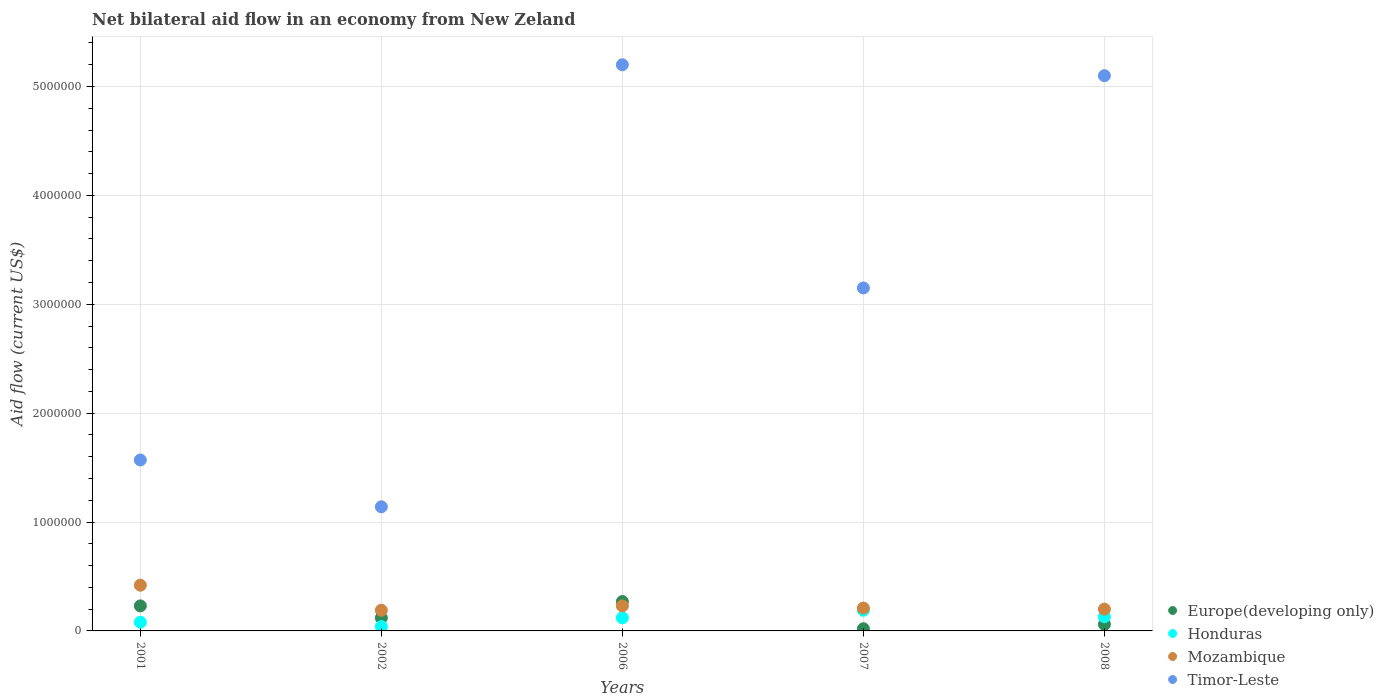How many different coloured dotlines are there?
Provide a succinct answer. 4. What is the net bilateral aid flow in Timor-Leste in 2007?
Your response must be concise. 3.15e+06. Across all years, what is the minimum net bilateral aid flow in Timor-Leste?
Give a very brief answer. 1.14e+06. In which year was the net bilateral aid flow in Timor-Leste minimum?
Provide a succinct answer. 2002. What is the total net bilateral aid flow in Timor-Leste in the graph?
Offer a very short reply. 1.62e+07. What is the difference between the net bilateral aid flow in Mozambique in 2001 and that in 2007?
Provide a short and direct response. 2.10e+05. What is the difference between the net bilateral aid flow in Europe(developing only) in 2002 and the net bilateral aid flow in Timor-Leste in 2007?
Your response must be concise. -3.03e+06. In the year 2008, what is the difference between the net bilateral aid flow in Honduras and net bilateral aid flow in Mozambique?
Your answer should be compact. -7.00e+04. In how many years, is the net bilateral aid flow in Timor-Leste greater than 3200000 US$?
Make the answer very short. 2. What is the ratio of the net bilateral aid flow in Mozambique in 2007 to that in 2008?
Your answer should be compact. 1.05. Is the sum of the net bilateral aid flow in Timor-Leste in 2001 and 2007 greater than the maximum net bilateral aid flow in Europe(developing only) across all years?
Your answer should be compact. Yes. Does the net bilateral aid flow in Mozambique monotonically increase over the years?
Provide a succinct answer. No. How many years are there in the graph?
Give a very brief answer. 5. What is the difference between two consecutive major ticks on the Y-axis?
Provide a short and direct response. 1.00e+06. Are the values on the major ticks of Y-axis written in scientific E-notation?
Provide a succinct answer. No. Where does the legend appear in the graph?
Ensure brevity in your answer.  Bottom right. How are the legend labels stacked?
Offer a terse response. Vertical. What is the title of the graph?
Your answer should be very brief. Net bilateral aid flow in an economy from New Zeland. Does "Turkmenistan" appear as one of the legend labels in the graph?
Provide a short and direct response. No. What is the label or title of the Y-axis?
Give a very brief answer. Aid flow (current US$). What is the Aid flow (current US$) in Honduras in 2001?
Ensure brevity in your answer.  8.00e+04. What is the Aid flow (current US$) in Timor-Leste in 2001?
Make the answer very short. 1.57e+06. What is the Aid flow (current US$) in Europe(developing only) in 2002?
Keep it short and to the point. 1.20e+05. What is the Aid flow (current US$) of Honduras in 2002?
Make the answer very short. 4.00e+04. What is the Aid flow (current US$) of Mozambique in 2002?
Keep it short and to the point. 1.90e+05. What is the Aid flow (current US$) of Timor-Leste in 2002?
Offer a terse response. 1.14e+06. What is the Aid flow (current US$) in Honduras in 2006?
Provide a succinct answer. 1.20e+05. What is the Aid flow (current US$) of Timor-Leste in 2006?
Provide a succinct answer. 5.20e+06. What is the Aid flow (current US$) of Timor-Leste in 2007?
Offer a terse response. 3.15e+06. What is the Aid flow (current US$) of Honduras in 2008?
Your answer should be compact. 1.30e+05. What is the Aid flow (current US$) of Timor-Leste in 2008?
Ensure brevity in your answer.  5.10e+06. Across all years, what is the maximum Aid flow (current US$) in Timor-Leste?
Give a very brief answer. 5.20e+06. Across all years, what is the minimum Aid flow (current US$) in Europe(developing only)?
Provide a succinct answer. 2.00e+04. Across all years, what is the minimum Aid flow (current US$) in Honduras?
Give a very brief answer. 4.00e+04. Across all years, what is the minimum Aid flow (current US$) in Mozambique?
Provide a succinct answer. 1.90e+05. Across all years, what is the minimum Aid flow (current US$) in Timor-Leste?
Ensure brevity in your answer.  1.14e+06. What is the total Aid flow (current US$) of Europe(developing only) in the graph?
Offer a terse response. 7.00e+05. What is the total Aid flow (current US$) of Honduras in the graph?
Offer a very short reply. 5.60e+05. What is the total Aid flow (current US$) of Mozambique in the graph?
Give a very brief answer. 1.25e+06. What is the total Aid flow (current US$) of Timor-Leste in the graph?
Give a very brief answer. 1.62e+07. What is the difference between the Aid flow (current US$) in Honduras in 2001 and that in 2002?
Make the answer very short. 4.00e+04. What is the difference between the Aid flow (current US$) in Mozambique in 2001 and that in 2002?
Ensure brevity in your answer.  2.30e+05. What is the difference between the Aid flow (current US$) in Mozambique in 2001 and that in 2006?
Give a very brief answer. 1.90e+05. What is the difference between the Aid flow (current US$) of Timor-Leste in 2001 and that in 2006?
Provide a succinct answer. -3.63e+06. What is the difference between the Aid flow (current US$) in Honduras in 2001 and that in 2007?
Provide a short and direct response. -1.10e+05. What is the difference between the Aid flow (current US$) of Timor-Leste in 2001 and that in 2007?
Offer a terse response. -1.58e+06. What is the difference between the Aid flow (current US$) of Europe(developing only) in 2001 and that in 2008?
Your answer should be compact. 1.70e+05. What is the difference between the Aid flow (current US$) of Timor-Leste in 2001 and that in 2008?
Offer a very short reply. -3.53e+06. What is the difference between the Aid flow (current US$) of Europe(developing only) in 2002 and that in 2006?
Keep it short and to the point. -1.50e+05. What is the difference between the Aid flow (current US$) of Mozambique in 2002 and that in 2006?
Your response must be concise. -4.00e+04. What is the difference between the Aid flow (current US$) of Timor-Leste in 2002 and that in 2006?
Keep it short and to the point. -4.06e+06. What is the difference between the Aid flow (current US$) of Europe(developing only) in 2002 and that in 2007?
Ensure brevity in your answer.  1.00e+05. What is the difference between the Aid flow (current US$) of Honduras in 2002 and that in 2007?
Offer a terse response. -1.50e+05. What is the difference between the Aid flow (current US$) in Mozambique in 2002 and that in 2007?
Provide a succinct answer. -2.00e+04. What is the difference between the Aid flow (current US$) of Timor-Leste in 2002 and that in 2007?
Give a very brief answer. -2.01e+06. What is the difference between the Aid flow (current US$) in Timor-Leste in 2002 and that in 2008?
Ensure brevity in your answer.  -3.96e+06. What is the difference between the Aid flow (current US$) of Europe(developing only) in 2006 and that in 2007?
Your answer should be very brief. 2.50e+05. What is the difference between the Aid flow (current US$) in Honduras in 2006 and that in 2007?
Your answer should be compact. -7.00e+04. What is the difference between the Aid flow (current US$) of Timor-Leste in 2006 and that in 2007?
Give a very brief answer. 2.05e+06. What is the difference between the Aid flow (current US$) in Europe(developing only) in 2006 and that in 2008?
Your answer should be very brief. 2.10e+05. What is the difference between the Aid flow (current US$) of Honduras in 2006 and that in 2008?
Your answer should be compact. -10000. What is the difference between the Aid flow (current US$) in Mozambique in 2006 and that in 2008?
Your answer should be compact. 3.00e+04. What is the difference between the Aid flow (current US$) of Timor-Leste in 2006 and that in 2008?
Provide a short and direct response. 1.00e+05. What is the difference between the Aid flow (current US$) of Honduras in 2007 and that in 2008?
Provide a short and direct response. 6.00e+04. What is the difference between the Aid flow (current US$) in Mozambique in 2007 and that in 2008?
Make the answer very short. 10000. What is the difference between the Aid flow (current US$) of Timor-Leste in 2007 and that in 2008?
Your answer should be compact. -1.95e+06. What is the difference between the Aid flow (current US$) of Europe(developing only) in 2001 and the Aid flow (current US$) of Honduras in 2002?
Ensure brevity in your answer.  1.90e+05. What is the difference between the Aid flow (current US$) of Europe(developing only) in 2001 and the Aid flow (current US$) of Timor-Leste in 2002?
Offer a terse response. -9.10e+05. What is the difference between the Aid flow (current US$) of Honduras in 2001 and the Aid flow (current US$) of Timor-Leste in 2002?
Provide a short and direct response. -1.06e+06. What is the difference between the Aid flow (current US$) in Mozambique in 2001 and the Aid flow (current US$) in Timor-Leste in 2002?
Give a very brief answer. -7.20e+05. What is the difference between the Aid flow (current US$) in Europe(developing only) in 2001 and the Aid flow (current US$) in Honduras in 2006?
Provide a succinct answer. 1.10e+05. What is the difference between the Aid flow (current US$) in Europe(developing only) in 2001 and the Aid flow (current US$) in Mozambique in 2006?
Your answer should be very brief. 0. What is the difference between the Aid flow (current US$) of Europe(developing only) in 2001 and the Aid flow (current US$) of Timor-Leste in 2006?
Ensure brevity in your answer.  -4.97e+06. What is the difference between the Aid flow (current US$) in Honduras in 2001 and the Aid flow (current US$) in Mozambique in 2006?
Make the answer very short. -1.50e+05. What is the difference between the Aid flow (current US$) of Honduras in 2001 and the Aid flow (current US$) of Timor-Leste in 2006?
Give a very brief answer. -5.12e+06. What is the difference between the Aid flow (current US$) of Mozambique in 2001 and the Aid flow (current US$) of Timor-Leste in 2006?
Offer a very short reply. -4.78e+06. What is the difference between the Aid flow (current US$) in Europe(developing only) in 2001 and the Aid flow (current US$) in Honduras in 2007?
Offer a terse response. 4.00e+04. What is the difference between the Aid flow (current US$) in Europe(developing only) in 2001 and the Aid flow (current US$) in Timor-Leste in 2007?
Your answer should be compact. -2.92e+06. What is the difference between the Aid flow (current US$) of Honduras in 2001 and the Aid flow (current US$) of Timor-Leste in 2007?
Provide a succinct answer. -3.07e+06. What is the difference between the Aid flow (current US$) of Mozambique in 2001 and the Aid flow (current US$) of Timor-Leste in 2007?
Keep it short and to the point. -2.73e+06. What is the difference between the Aid flow (current US$) of Europe(developing only) in 2001 and the Aid flow (current US$) of Honduras in 2008?
Offer a very short reply. 1.00e+05. What is the difference between the Aid flow (current US$) of Europe(developing only) in 2001 and the Aid flow (current US$) of Mozambique in 2008?
Make the answer very short. 3.00e+04. What is the difference between the Aid flow (current US$) in Europe(developing only) in 2001 and the Aid flow (current US$) in Timor-Leste in 2008?
Your answer should be very brief. -4.87e+06. What is the difference between the Aid flow (current US$) of Honduras in 2001 and the Aid flow (current US$) of Mozambique in 2008?
Keep it short and to the point. -1.20e+05. What is the difference between the Aid flow (current US$) of Honduras in 2001 and the Aid flow (current US$) of Timor-Leste in 2008?
Offer a very short reply. -5.02e+06. What is the difference between the Aid flow (current US$) of Mozambique in 2001 and the Aid flow (current US$) of Timor-Leste in 2008?
Offer a very short reply. -4.68e+06. What is the difference between the Aid flow (current US$) in Europe(developing only) in 2002 and the Aid flow (current US$) in Mozambique in 2006?
Make the answer very short. -1.10e+05. What is the difference between the Aid flow (current US$) of Europe(developing only) in 2002 and the Aid flow (current US$) of Timor-Leste in 2006?
Provide a short and direct response. -5.08e+06. What is the difference between the Aid flow (current US$) in Honduras in 2002 and the Aid flow (current US$) in Mozambique in 2006?
Ensure brevity in your answer.  -1.90e+05. What is the difference between the Aid flow (current US$) of Honduras in 2002 and the Aid flow (current US$) of Timor-Leste in 2006?
Offer a very short reply. -5.16e+06. What is the difference between the Aid flow (current US$) in Mozambique in 2002 and the Aid flow (current US$) in Timor-Leste in 2006?
Give a very brief answer. -5.01e+06. What is the difference between the Aid flow (current US$) of Europe(developing only) in 2002 and the Aid flow (current US$) of Honduras in 2007?
Offer a very short reply. -7.00e+04. What is the difference between the Aid flow (current US$) of Europe(developing only) in 2002 and the Aid flow (current US$) of Timor-Leste in 2007?
Provide a succinct answer. -3.03e+06. What is the difference between the Aid flow (current US$) in Honduras in 2002 and the Aid flow (current US$) in Mozambique in 2007?
Give a very brief answer. -1.70e+05. What is the difference between the Aid flow (current US$) of Honduras in 2002 and the Aid flow (current US$) of Timor-Leste in 2007?
Provide a succinct answer. -3.11e+06. What is the difference between the Aid flow (current US$) in Mozambique in 2002 and the Aid flow (current US$) in Timor-Leste in 2007?
Ensure brevity in your answer.  -2.96e+06. What is the difference between the Aid flow (current US$) in Europe(developing only) in 2002 and the Aid flow (current US$) in Timor-Leste in 2008?
Your response must be concise. -4.98e+06. What is the difference between the Aid flow (current US$) of Honduras in 2002 and the Aid flow (current US$) of Mozambique in 2008?
Your answer should be compact. -1.60e+05. What is the difference between the Aid flow (current US$) of Honduras in 2002 and the Aid flow (current US$) of Timor-Leste in 2008?
Offer a terse response. -5.06e+06. What is the difference between the Aid flow (current US$) in Mozambique in 2002 and the Aid flow (current US$) in Timor-Leste in 2008?
Your response must be concise. -4.91e+06. What is the difference between the Aid flow (current US$) of Europe(developing only) in 2006 and the Aid flow (current US$) of Honduras in 2007?
Your response must be concise. 8.00e+04. What is the difference between the Aid flow (current US$) of Europe(developing only) in 2006 and the Aid flow (current US$) of Mozambique in 2007?
Provide a succinct answer. 6.00e+04. What is the difference between the Aid flow (current US$) of Europe(developing only) in 2006 and the Aid flow (current US$) of Timor-Leste in 2007?
Your answer should be compact. -2.88e+06. What is the difference between the Aid flow (current US$) in Honduras in 2006 and the Aid flow (current US$) in Mozambique in 2007?
Ensure brevity in your answer.  -9.00e+04. What is the difference between the Aid flow (current US$) in Honduras in 2006 and the Aid flow (current US$) in Timor-Leste in 2007?
Provide a short and direct response. -3.03e+06. What is the difference between the Aid flow (current US$) of Mozambique in 2006 and the Aid flow (current US$) of Timor-Leste in 2007?
Keep it short and to the point. -2.92e+06. What is the difference between the Aid flow (current US$) in Europe(developing only) in 2006 and the Aid flow (current US$) in Mozambique in 2008?
Make the answer very short. 7.00e+04. What is the difference between the Aid flow (current US$) of Europe(developing only) in 2006 and the Aid flow (current US$) of Timor-Leste in 2008?
Your response must be concise. -4.83e+06. What is the difference between the Aid flow (current US$) in Honduras in 2006 and the Aid flow (current US$) in Mozambique in 2008?
Offer a terse response. -8.00e+04. What is the difference between the Aid flow (current US$) of Honduras in 2006 and the Aid flow (current US$) of Timor-Leste in 2008?
Your response must be concise. -4.98e+06. What is the difference between the Aid flow (current US$) in Mozambique in 2006 and the Aid flow (current US$) in Timor-Leste in 2008?
Your response must be concise. -4.87e+06. What is the difference between the Aid flow (current US$) of Europe(developing only) in 2007 and the Aid flow (current US$) of Timor-Leste in 2008?
Offer a terse response. -5.08e+06. What is the difference between the Aid flow (current US$) of Honduras in 2007 and the Aid flow (current US$) of Mozambique in 2008?
Ensure brevity in your answer.  -10000. What is the difference between the Aid flow (current US$) of Honduras in 2007 and the Aid flow (current US$) of Timor-Leste in 2008?
Keep it short and to the point. -4.91e+06. What is the difference between the Aid flow (current US$) in Mozambique in 2007 and the Aid flow (current US$) in Timor-Leste in 2008?
Ensure brevity in your answer.  -4.89e+06. What is the average Aid flow (current US$) in Europe(developing only) per year?
Your answer should be very brief. 1.40e+05. What is the average Aid flow (current US$) in Honduras per year?
Your answer should be compact. 1.12e+05. What is the average Aid flow (current US$) in Mozambique per year?
Ensure brevity in your answer.  2.50e+05. What is the average Aid flow (current US$) of Timor-Leste per year?
Ensure brevity in your answer.  3.23e+06. In the year 2001, what is the difference between the Aid flow (current US$) of Europe(developing only) and Aid flow (current US$) of Timor-Leste?
Ensure brevity in your answer.  -1.34e+06. In the year 2001, what is the difference between the Aid flow (current US$) in Honduras and Aid flow (current US$) in Mozambique?
Your response must be concise. -3.40e+05. In the year 2001, what is the difference between the Aid flow (current US$) of Honduras and Aid flow (current US$) of Timor-Leste?
Make the answer very short. -1.49e+06. In the year 2001, what is the difference between the Aid flow (current US$) in Mozambique and Aid flow (current US$) in Timor-Leste?
Offer a very short reply. -1.15e+06. In the year 2002, what is the difference between the Aid flow (current US$) of Europe(developing only) and Aid flow (current US$) of Honduras?
Provide a short and direct response. 8.00e+04. In the year 2002, what is the difference between the Aid flow (current US$) of Europe(developing only) and Aid flow (current US$) of Mozambique?
Your answer should be very brief. -7.00e+04. In the year 2002, what is the difference between the Aid flow (current US$) of Europe(developing only) and Aid flow (current US$) of Timor-Leste?
Offer a very short reply. -1.02e+06. In the year 2002, what is the difference between the Aid flow (current US$) in Honduras and Aid flow (current US$) in Timor-Leste?
Your answer should be very brief. -1.10e+06. In the year 2002, what is the difference between the Aid flow (current US$) of Mozambique and Aid flow (current US$) of Timor-Leste?
Your response must be concise. -9.50e+05. In the year 2006, what is the difference between the Aid flow (current US$) in Europe(developing only) and Aid flow (current US$) in Honduras?
Your answer should be compact. 1.50e+05. In the year 2006, what is the difference between the Aid flow (current US$) in Europe(developing only) and Aid flow (current US$) in Timor-Leste?
Make the answer very short. -4.93e+06. In the year 2006, what is the difference between the Aid flow (current US$) in Honduras and Aid flow (current US$) in Mozambique?
Your answer should be very brief. -1.10e+05. In the year 2006, what is the difference between the Aid flow (current US$) of Honduras and Aid flow (current US$) of Timor-Leste?
Ensure brevity in your answer.  -5.08e+06. In the year 2006, what is the difference between the Aid flow (current US$) in Mozambique and Aid flow (current US$) in Timor-Leste?
Provide a succinct answer. -4.97e+06. In the year 2007, what is the difference between the Aid flow (current US$) in Europe(developing only) and Aid flow (current US$) in Timor-Leste?
Provide a succinct answer. -3.13e+06. In the year 2007, what is the difference between the Aid flow (current US$) in Honduras and Aid flow (current US$) in Mozambique?
Offer a very short reply. -2.00e+04. In the year 2007, what is the difference between the Aid flow (current US$) of Honduras and Aid flow (current US$) of Timor-Leste?
Your answer should be very brief. -2.96e+06. In the year 2007, what is the difference between the Aid flow (current US$) in Mozambique and Aid flow (current US$) in Timor-Leste?
Keep it short and to the point. -2.94e+06. In the year 2008, what is the difference between the Aid flow (current US$) in Europe(developing only) and Aid flow (current US$) in Honduras?
Provide a short and direct response. -7.00e+04. In the year 2008, what is the difference between the Aid flow (current US$) of Europe(developing only) and Aid flow (current US$) of Mozambique?
Offer a very short reply. -1.40e+05. In the year 2008, what is the difference between the Aid flow (current US$) of Europe(developing only) and Aid flow (current US$) of Timor-Leste?
Ensure brevity in your answer.  -5.04e+06. In the year 2008, what is the difference between the Aid flow (current US$) of Honduras and Aid flow (current US$) of Timor-Leste?
Provide a short and direct response. -4.97e+06. In the year 2008, what is the difference between the Aid flow (current US$) in Mozambique and Aid flow (current US$) in Timor-Leste?
Offer a very short reply. -4.90e+06. What is the ratio of the Aid flow (current US$) in Europe(developing only) in 2001 to that in 2002?
Offer a terse response. 1.92. What is the ratio of the Aid flow (current US$) of Honduras in 2001 to that in 2002?
Provide a short and direct response. 2. What is the ratio of the Aid flow (current US$) of Mozambique in 2001 to that in 2002?
Your answer should be compact. 2.21. What is the ratio of the Aid flow (current US$) of Timor-Leste in 2001 to that in 2002?
Offer a very short reply. 1.38. What is the ratio of the Aid flow (current US$) in Europe(developing only) in 2001 to that in 2006?
Your response must be concise. 0.85. What is the ratio of the Aid flow (current US$) of Mozambique in 2001 to that in 2006?
Offer a very short reply. 1.83. What is the ratio of the Aid flow (current US$) in Timor-Leste in 2001 to that in 2006?
Provide a succinct answer. 0.3. What is the ratio of the Aid flow (current US$) in Europe(developing only) in 2001 to that in 2007?
Give a very brief answer. 11.5. What is the ratio of the Aid flow (current US$) of Honduras in 2001 to that in 2007?
Provide a short and direct response. 0.42. What is the ratio of the Aid flow (current US$) in Timor-Leste in 2001 to that in 2007?
Provide a short and direct response. 0.5. What is the ratio of the Aid flow (current US$) of Europe(developing only) in 2001 to that in 2008?
Your answer should be very brief. 3.83. What is the ratio of the Aid flow (current US$) in Honduras in 2001 to that in 2008?
Provide a short and direct response. 0.62. What is the ratio of the Aid flow (current US$) in Mozambique in 2001 to that in 2008?
Ensure brevity in your answer.  2.1. What is the ratio of the Aid flow (current US$) of Timor-Leste in 2001 to that in 2008?
Your answer should be very brief. 0.31. What is the ratio of the Aid flow (current US$) in Europe(developing only) in 2002 to that in 2006?
Give a very brief answer. 0.44. What is the ratio of the Aid flow (current US$) in Mozambique in 2002 to that in 2006?
Your answer should be very brief. 0.83. What is the ratio of the Aid flow (current US$) of Timor-Leste in 2002 to that in 2006?
Provide a short and direct response. 0.22. What is the ratio of the Aid flow (current US$) of Europe(developing only) in 2002 to that in 2007?
Make the answer very short. 6. What is the ratio of the Aid flow (current US$) in Honduras in 2002 to that in 2007?
Give a very brief answer. 0.21. What is the ratio of the Aid flow (current US$) of Mozambique in 2002 to that in 2007?
Your answer should be compact. 0.9. What is the ratio of the Aid flow (current US$) of Timor-Leste in 2002 to that in 2007?
Your answer should be compact. 0.36. What is the ratio of the Aid flow (current US$) of Honduras in 2002 to that in 2008?
Offer a very short reply. 0.31. What is the ratio of the Aid flow (current US$) of Timor-Leste in 2002 to that in 2008?
Your answer should be very brief. 0.22. What is the ratio of the Aid flow (current US$) in Honduras in 2006 to that in 2007?
Offer a very short reply. 0.63. What is the ratio of the Aid flow (current US$) of Mozambique in 2006 to that in 2007?
Give a very brief answer. 1.1. What is the ratio of the Aid flow (current US$) in Timor-Leste in 2006 to that in 2007?
Your response must be concise. 1.65. What is the ratio of the Aid flow (current US$) in Mozambique in 2006 to that in 2008?
Make the answer very short. 1.15. What is the ratio of the Aid flow (current US$) of Timor-Leste in 2006 to that in 2008?
Your answer should be very brief. 1.02. What is the ratio of the Aid flow (current US$) of Honduras in 2007 to that in 2008?
Keep it short and to the point. 1.46. What is the ratio of the Aid flow (current US$) in Timor-Leste in 2007 to that in 2008?
Provide a short and direct response. 0.62. What is the difference between the highest and the second highest Aid flow (current US$) of Europe(developing only)?
Your answer should be compact. 4.00e+04. What is the difference between the highest and the lowest Aid flow (current US$) of Europe(developing only)?
Provide a short and direct response. 2.50e+05. What is the difference between the highest and the lowest Aid flow (current US$) in Honduras?
Ensure brevity in your answer.  1.50e+05. What is the difference between the highest and the lowest Aid flow (current US$) of Mozambique?
Make the answer very short. 2.30e+05. What is the difference between the highest and the lowest Aid flow (current US$) in Timor-Leste?
Give a very brief answer. 4.06e+06. 